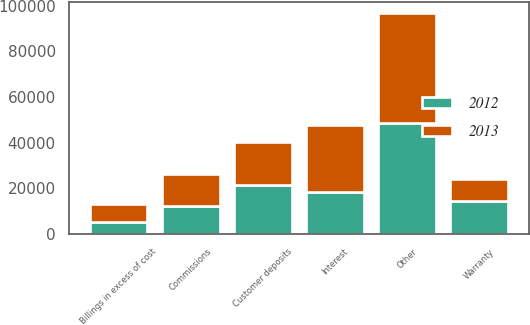Convert chart. <chart><loc_0><loc_0><loc_500><loc_500><stacked_bar_chart><ecel><fcel>Interest<fcel>Customer deposits<fcel>Commissions<fcel>Warranty<fcel>Billings in excess of cost<fcel>Other<nl><fcel>2012<fcel>18285<fcel>21438<fcel>12030<fcel>14336<fcel>5016<fcel>48640<nl><fcel>2013<fcel>29537<fcel>18738<fcel>14372<fcel>9755<fcel>7912<fcel>48037<nl></chart> 